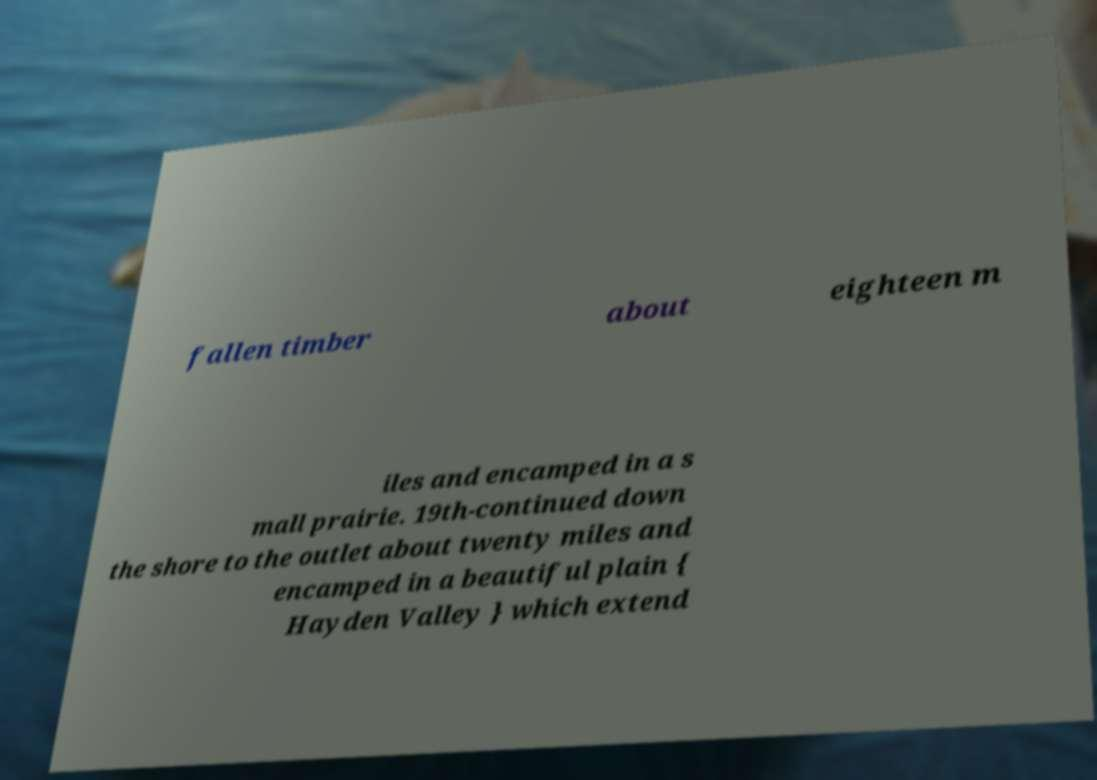I need the written content from this picture converted into text. Can you do that? fallen timber about eighteen m iles and encamped in a s mall prairie. 19th-continued down the shore to the outlet about twenty miles and encamped in a beautiful plain { Hayden Valley } which extend 